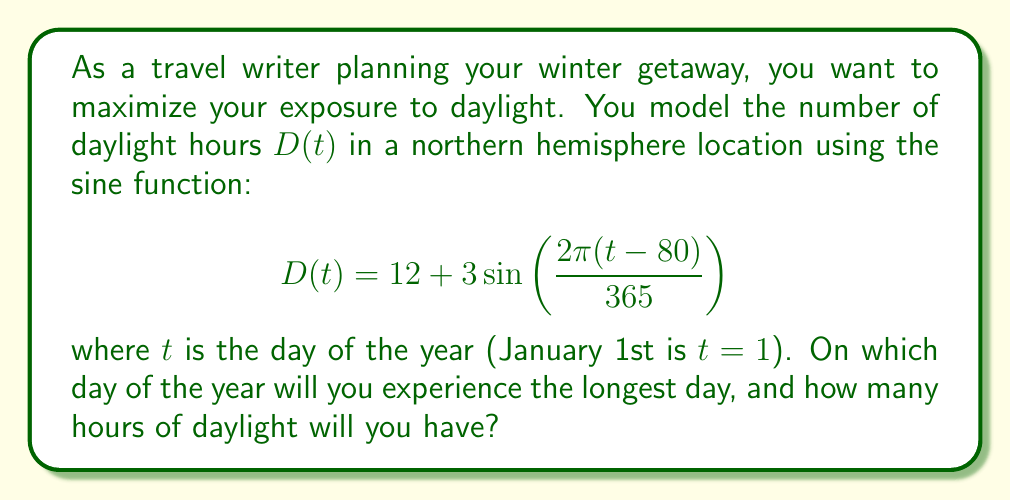What is the answer to this math problem? To find the day with the longest daylight hours and the number of hours, we need to follow these steps:

1) The sine function reaches its maximum value when its argument is $\frac{\pi}{2}$ or 90°. So, we need to solve:

   $$\frac{2\pi(t-80)}{365} = \frac{\pi}{2}$$

2) Solving for $t$:
   
   $$t-80 = \frac{365}{4} = 91.25$$
   $$t = 171.25$$

3) Since $t$ represents days, we round to the nearest whole number: 171.

4) This corresponds to June 20th (the summer solstice in the northern hemisphere).

5) To find the number of daylight hours on this day, we substitute $t=171$ into the original function:

   $$D(171) = 12 + 3\sin\left(\frac{2\pi(171-80)}{365}\right)$$
   $$= 12 + 3\sin\left(\frac{2\pi(91)}{365}\right)$$
   $$\approx 12 + 3 \approx 15$$

Therefore, on the longest day of the year (June 20th), there will be approximately 15 hours of daylight.
Answer: June 20th, 15 hours 